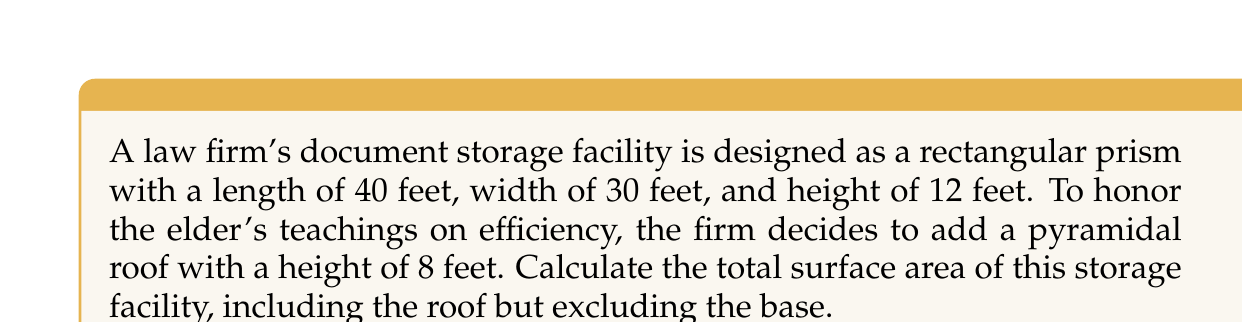Can you solve this math problem? Let's approach this step-by-step:

1) First, we need to calculate the surface area of the rectangular prism (without the top):
   - Front and back: $2 \times (40 \text{ ft} \times 12 \text{ ft}) = 960 \text{ ft}^2$
   - Left and right sides: $2 \times (30 \text{ ft} \times 12 \text{ ft}) = 720 \text{ ft}^2$
   
   Total for rectangular part: $960 + 720 = 1680 \text{ ft}^2$

2) Now, let's calculate the surface area of the pyramidal roof:
   - The base of the pyramid is $40 \text{ ft} \times 30 \text{ ft}$
   - We need to find the slant height of the pyramid using the Pythagorean theorem:
     $$\text{Slant height} = \sqrt{(20^2 + 15^2) + 8^2} = \sqrt{625 + 64} = \sqrt{689} \approx 26.25 \text{ ft}$$

3) The surface area of the pyramid is the sum of its four triangular faces:
   - Two triangles with base 40 ft: $2 \times \frac{1}{2} \times 40 \times 26.25 = 1050 \text{ ft}^2$
   - Two triangles with base 30 ft: $2 \times \frac{1}{2} \times 30 \times 26.25 = 787.5 \text{ ft}^2$
   
   Total for pyramidal roof: $1050 + 787.5 = 1837.5 \text{ ft}^2$

4) The total surface area is the sum of the rectangular part and the pyramidal roof:
   $1680 + 1837.5 = 3517.5 \text{ ft}^2$
Answer: $3517.5 \text{ ft}^2$ 